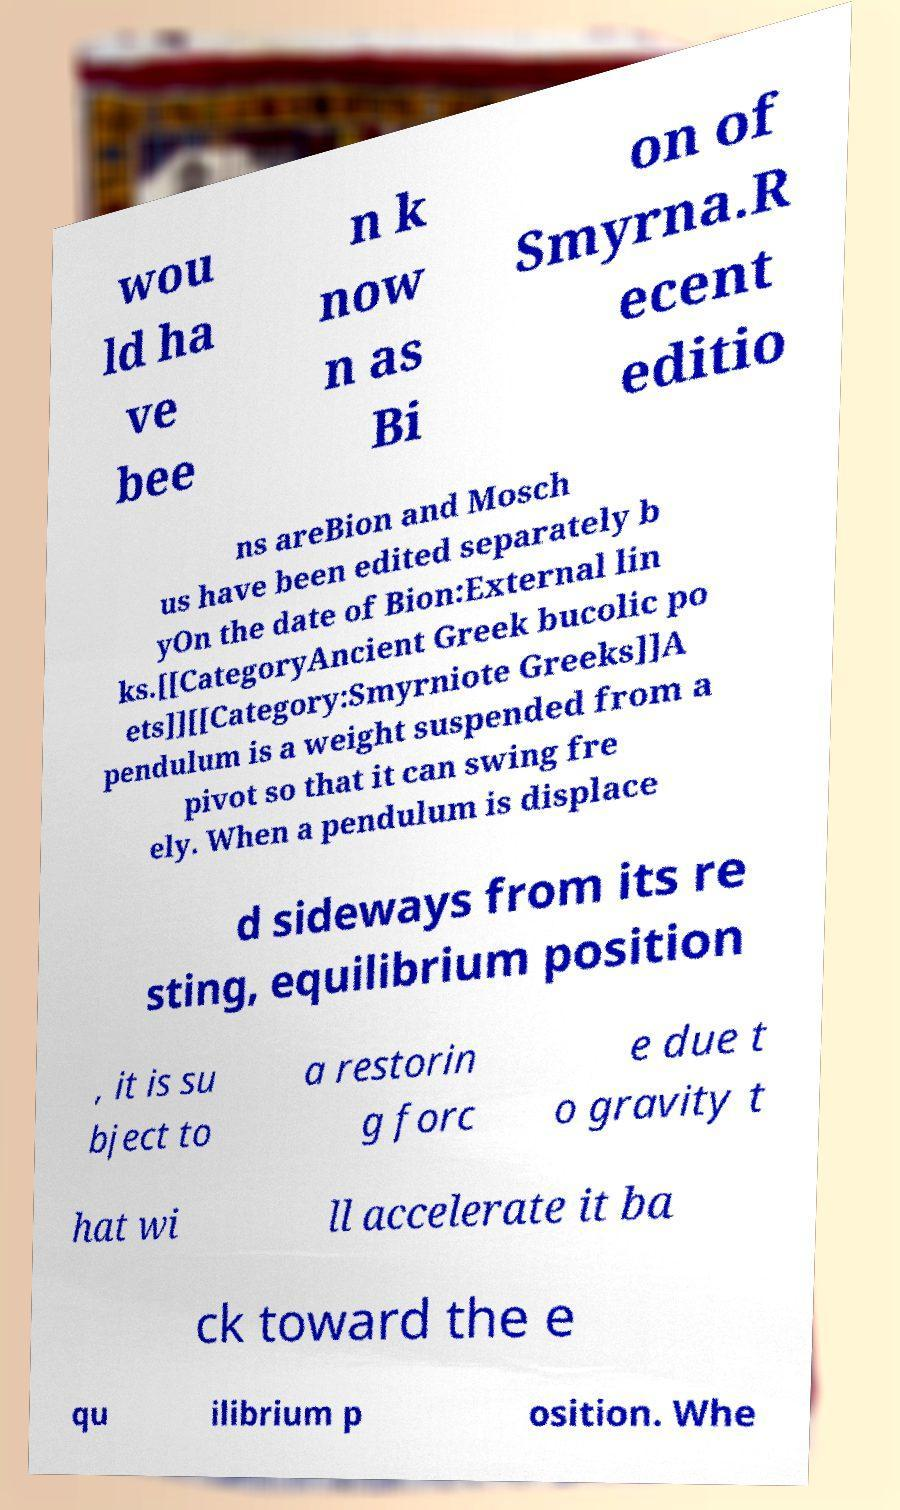For documentation purposes, I need the text within this image transcribed. Could you provide that? wou ld ha ve bee n k now n as Bi on of Smyrna.R ecent editio ns areBion and Mosch us have been edited separately b yOn the date of Bion:External lin ks.[[CategoryAncient Greek bucolic po ets]][[Category:Smyrniote Greeks]]A pendulum is a weight suspended from a pivot so that it can swing fre ely. When a pendulum is displace d sideways from its re sting, equilibrium position , it is su bject to a restorin g forc e due t o gravity t hat wi ll accelerate it ba ck toward the e qu ilibrium p osition. Whe 